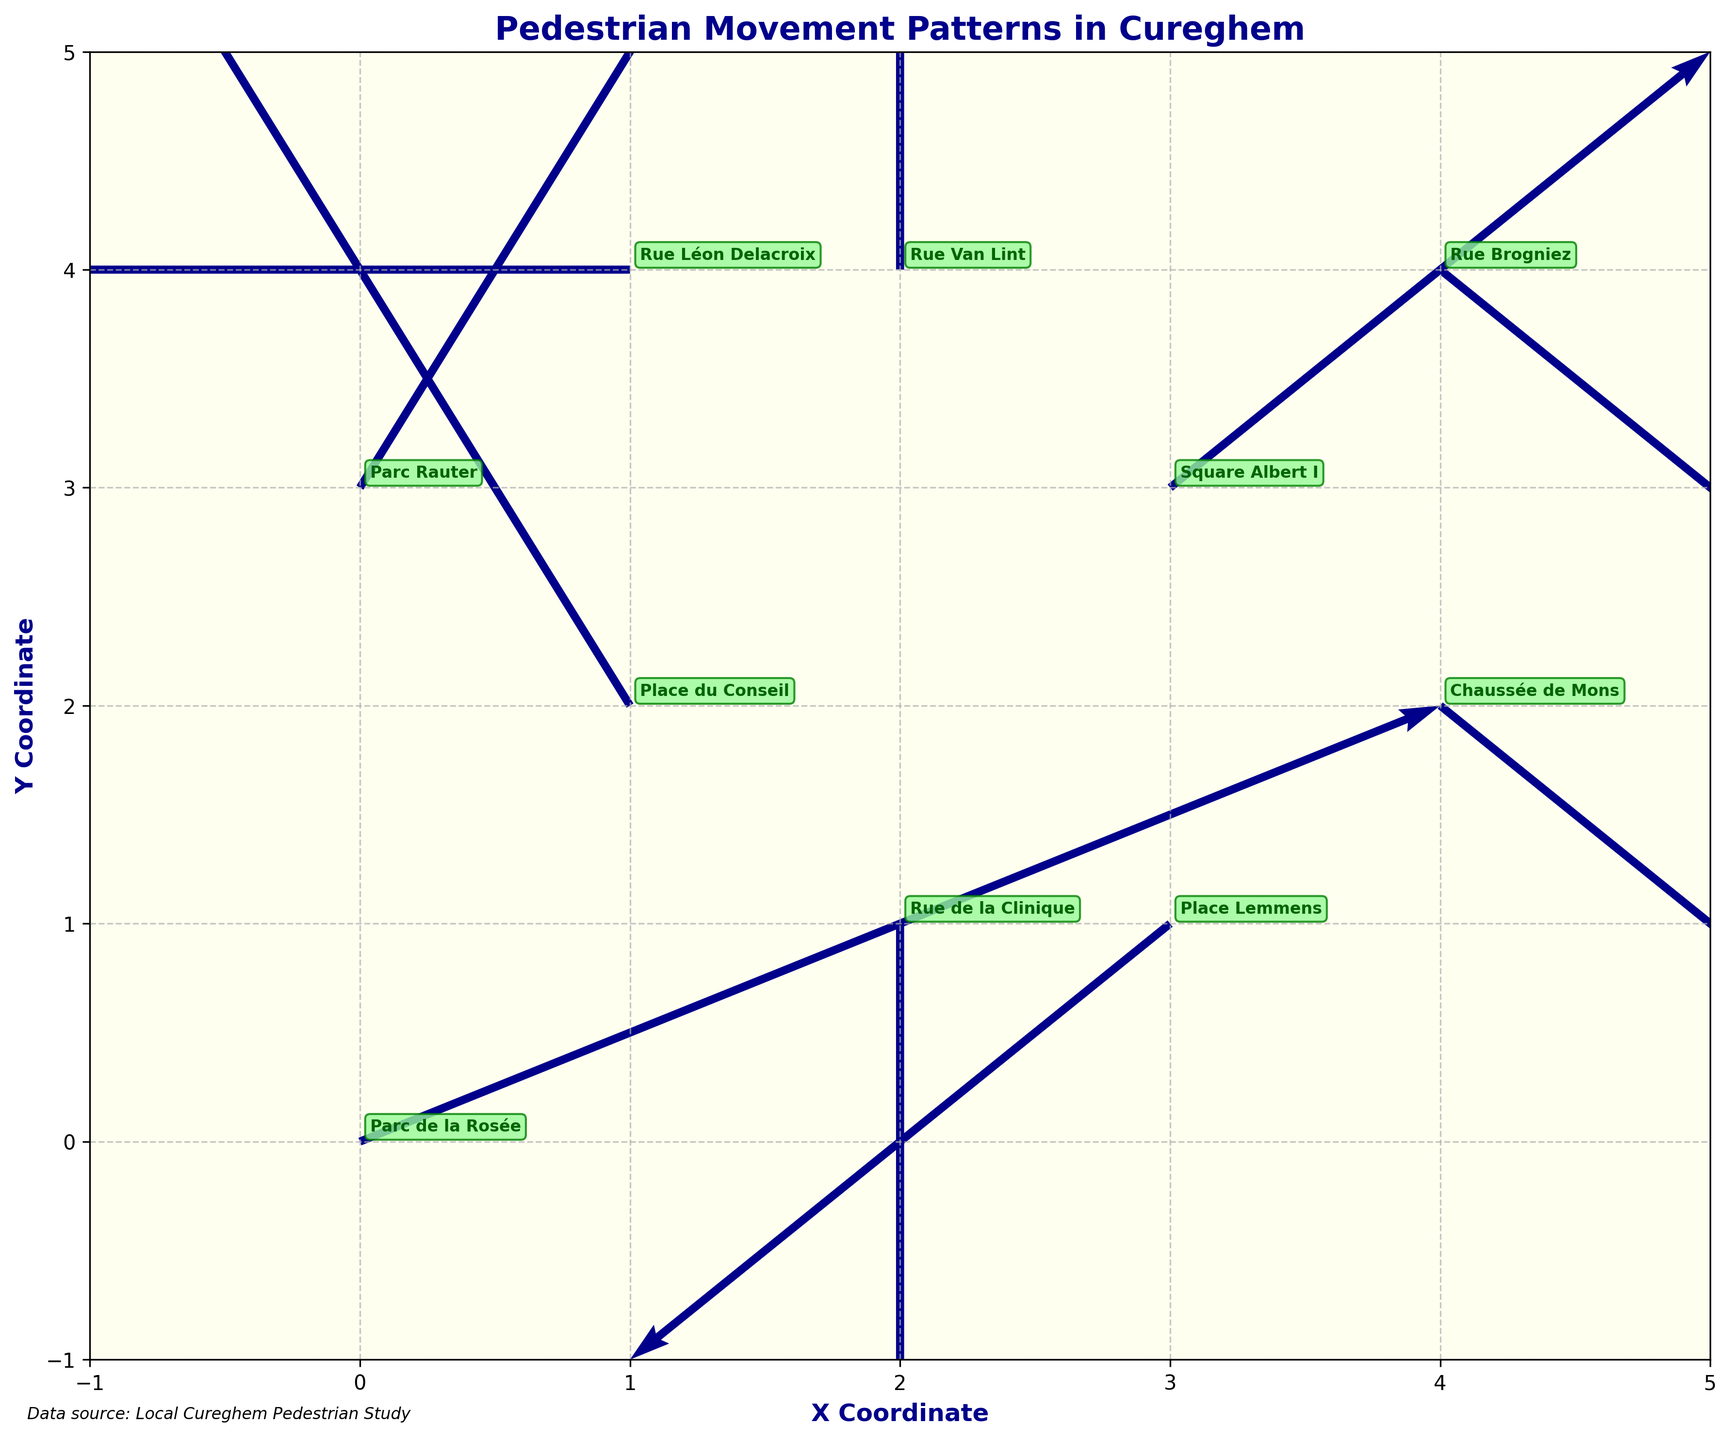What's the title of the figure? The title of the figure is displayed prominently at the top of the plot.
Answer: Pedestrian Movement Patterns in Cureghem What colors are used for the arrows and text labels? By visually inspecting the arrows and the text labels, one can see that the arrows are dark blue and the text labels are dark green on a pale green background.
Answer: Dark blue and dark green How many locations are shown in the plot? By counting the unique location labels annotated in the plot, one can see there are 10 different locations.
Answer: 10 Which location has the largest positive y-component of movement? By looking at the y-components of the arrows depicted visually, the largest positive y-component is 2. The locations with corresponding y-components of 2 are Place du Conseil, Rue Van Lint, and Parc Rauter.
Answer: Place du Conseil, Rue Van Lint, and Parc Rauter What are the x and y coordinates of Place Lemmens? According to the visual positions and the annotations in the plot, Place Lemmens is located at coordinates (3,1).
Answer: (3,1) Which location has the greatest combined magnitude of movement? To determine the combined magnitude, one must calculate the sum of the absolute values of u and v for each location. Rue Brogniez has the highest values (2, -2), resulting in a total magnitude of 4.
Answer: Rue Brogniez What direction does the arrow at Chaussée de Mons point to? From the quiver plot, the arrow at Chaussée de Mons has components (1, -1), which means it points to the northeast direction (positive x and negative y direction).
Answer: Northeast Which locations show no movement in one direction (either x or y)? By inspecting the u and v components, the locations with u=0 or v=0 are Rue de la Clinique and Rue Van Lint.
Answer: Rue de la Clinique and Rue Van Lint How does the pedestrian movement in Place Lemmens compare to Square Albert I? Comparing the vectors: Place Lemmens has (-1, -1) and Square Albert I has (1, 1). Place Lemmens shows a southwest movement, while Square Albert I shows a northeast movement.
Answer: Place Lemmens: Southwest, Square Albert I: Northeast 